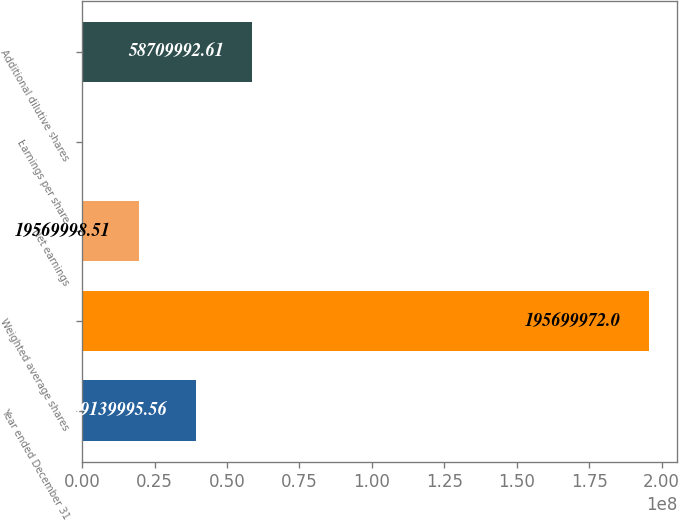Convert chart. <chart><loc_0><loc_0><loc_500><loc_500><bar_chart><fcel>Year ended December 31<fcel>Weighted average shares<fcel>Net earnings<fcel>Earnings per share<fcel>Additional dilutive shares<nl><fcel>3.914e+07<fcel>1.957e+08<fcel>1.957e+07<fcel>1.46<fcel>5.871e+07<nl></chart> 